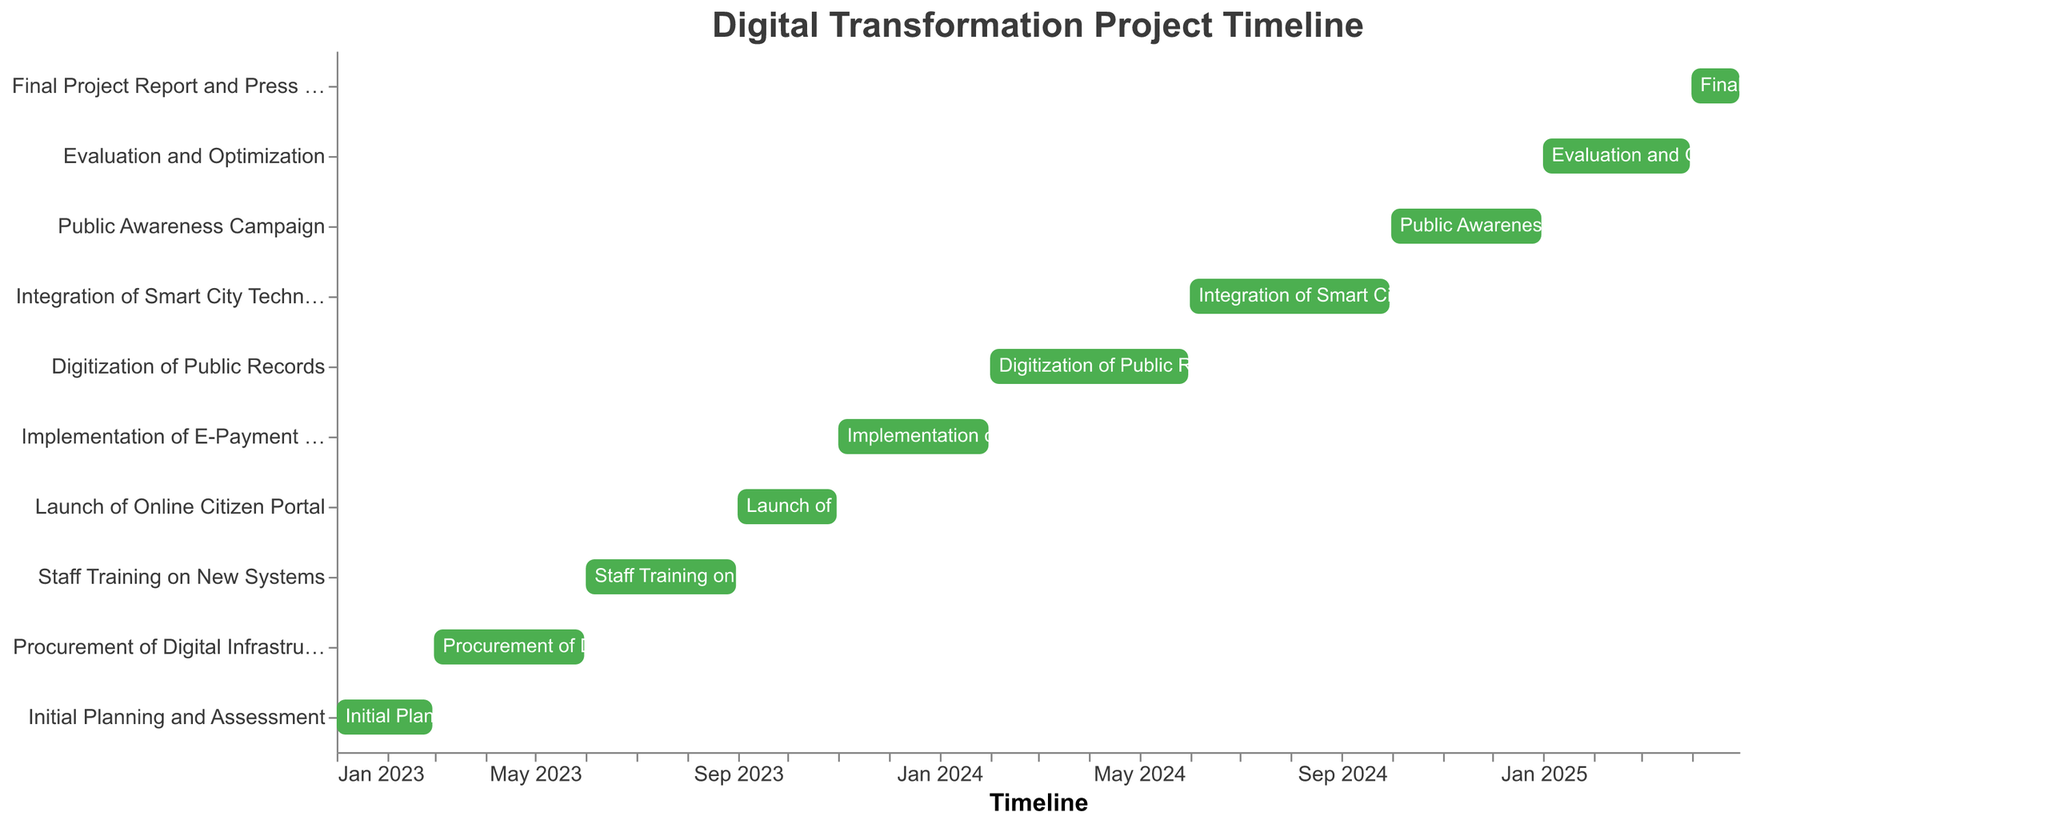How long is the entire digital transformation project expected to take? To find the total project duration, look at the start date of the first task and the end date of the last task. The project starts on January 1, 2023, and ends on April 30, 2025. The total duration is from January 2023 to April 2025.
Answer: 2 years and 4 months Which task has the shortest duration? By comparing the duration of each task, we can see "Final Project Report and Press Release" runs from April 1, 2025, to April 30, 2025. This task has a duration of only one month.
Answer: Final Project Report and Press Release What is the longest task duration in the project? To find the longest task duration, compare the start and end dates of each task. "Digitization of Public Records" spans from February 1, 2024, to May 31, 2024, which is four months. No other task is longer.
Answer: Digitization of Public Records How many tasks will be completed in the year 2024? By checking each task's start and end dates, we see the tasks fully within 2024 are "Digitization of Public Records," "Integration of Smart City Technologies," and "Public Awareness Campaign." Three tasks complete in 2024.
Answer: 3 Which two tasks overlap in their timelines? Check the tasks' start and end dates for overlaps. "Launch of Online Citizen Portal" (Sep 2023 - Oct 2023) overlaps with "Implementation of E-Payment System" (Nov 2023 - Jan 2024) since they fall close but don't overlap. Other tasks don't overlap significantly.
Answer: None During which period is "Staff Training on New Systems" conducted? Look at the timeline for the "Staff Training on New Systems" task. It starts on June 1, 2023, and ends on August 31, 2023.
Answer: June to August 2023 When will the "Public Awareness Campaign" begin and end? By checking the task labeled "Public Awareness Campaign," we see it starts on October 1, 2024, and ends on December 31, 2024.
Answer: October 1, 2024, to December 31, 2024 How many tasks are scheduled before the "Launch of Online Citizen Portal"? Count the tasks that end before September 1, 2023. There are three: "Initial Planning and Assessment," "Procurement of Digital Infrastructure," and "Staff Training on New Systems."
Answer: 3 When will the "Evaluation and Optimization" task occur? The "Evaluation and Optimization" task starts on January 1, 2025, and ends on March 31, 2025, according to the figure.
Answer: January 1, 2025, to March 31, 2025 